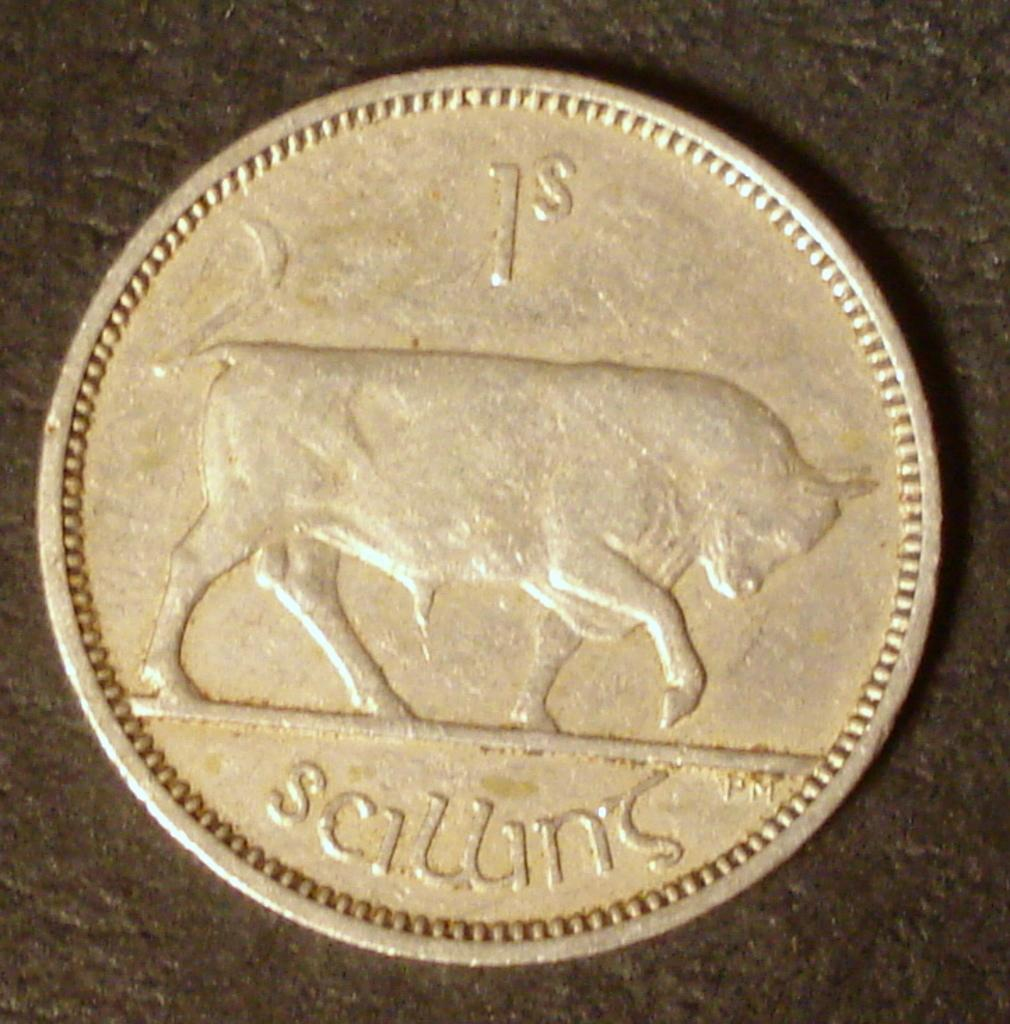<image>
Render a clear and concise summary of the photo. a close up of a coin for 1S and the image of a bull 